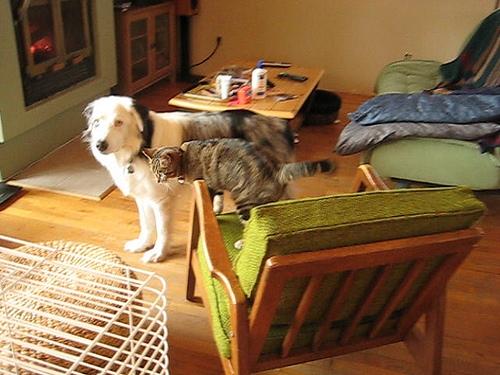What animal is it?
Give a very brief answer. Dog and cat. What is sitting on the chair?
Write a very short answer. Cat. Is someone on the couch?
Concise answer only. No. What animals are in this photo?
Write a very short answer. Cat and dog. What are the floors made of?
Short answer required. Wood. What is the cat on?
Short answer required. Chair. 